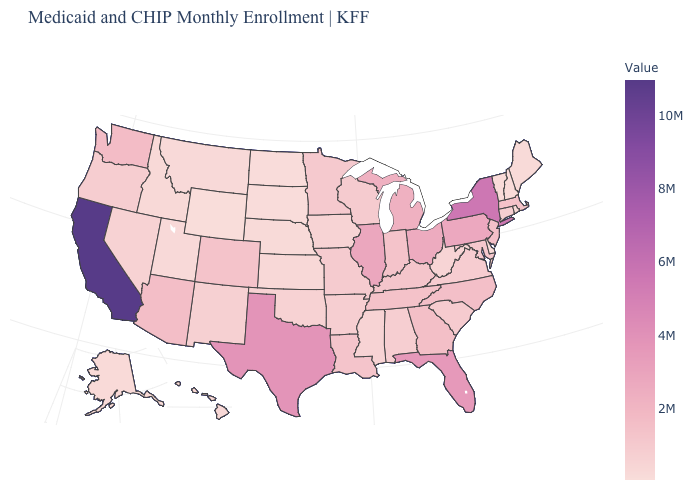Which states hav the highest value in the MidWest?
Be succinct. Illinois. Does Connecticut have a lower value than Texas?
Answer briefly. Yes. Is the legend a continuous bar?
Answer briefly. Yes. 